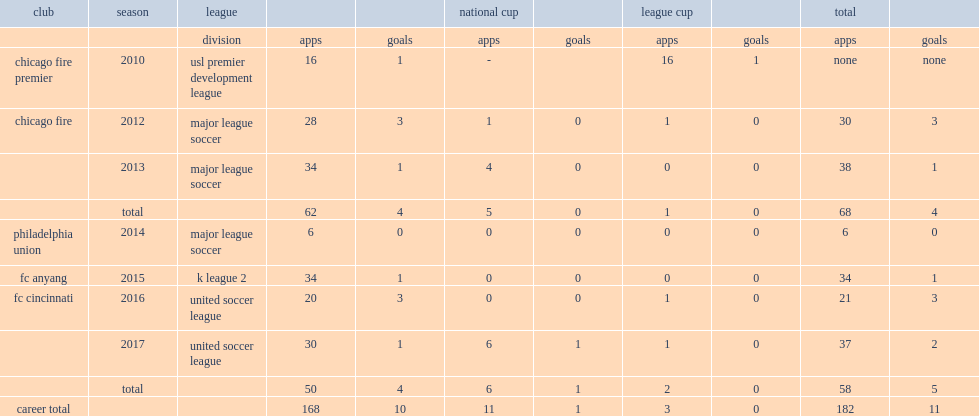In 2010, which league did berry play for the team chicago fire premier? Usl premier development league. 